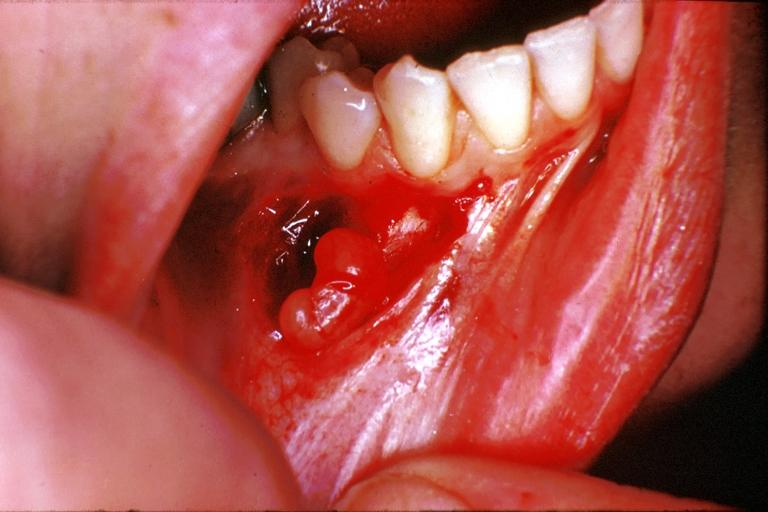what does this image show?
Answer the question using a single word or phrase. Traumatic neuroma 